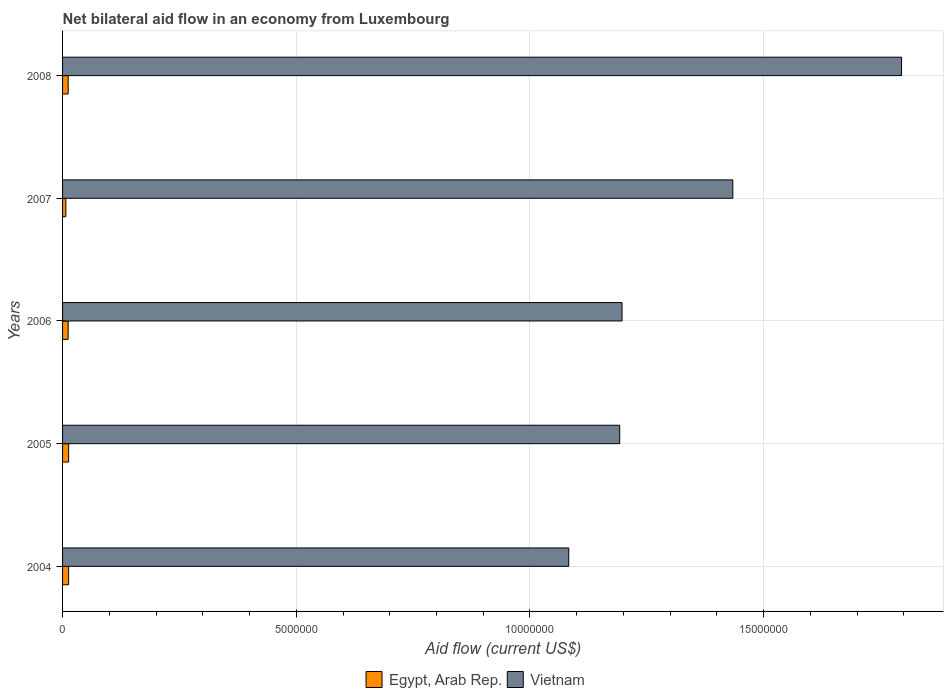How many groups of bars are there?
Your answer should be compact. 5. Are the number of bars per tick equal to the number of legend labels?
Your answer should be very brief. Yes. Are the number of bars on each tick of the Y-axis equal?
Your answer should be compact. Yes. How many bars are there on the 2nd tick from the bottom?
Keep it short and to the point. 2. What is the label of the 3rd group of bars from the top?
Ensure brevity in your answer.  2006. What is the net bilateral aid flow in Egypt, Arab Rep. in 2006?
Provide a succinct answer. 1.20e+05. Across all years, what is the maximum net bilateral aid flow in Vietnam?
Offer a very short reply. 1.80e+07. Across all years, what is the minimum net bilateral aid flow in Vietnam?
Make the answer very short. 1.08e+07. In which year was the net bilateral aid flow in Egypt, Arab Rep. maximum?
Make the answer very short. 2004. In which year was the net bilateral aid flow in Vietnam minimum?
Provide a short and direct response. 2004. What is the total net bilateral aid flow in Egypt, Arab Rep. in the graph?
Provide a short and direct response. 5.70e+05. What is the difference between the net bilateral aid flow in Egypt, Arab Rep. in 2004 and that in 2008?
Give a very brief answer. 10000. What is the difference between the net bilateral aid flow in Vietnam in 2005 and the net bilateral aid flow in Egypt, Arab Rep. in 2008?
Provide a short and direct response. 1.18e+07. What is the average net bilateral aid flow in Vietnam per year?
Provide a short and direct response. 1.34e+07. In the year 2007, what is the difference between the net bilateral aid flow in Vietnam and net bilateral aid flow in Egypt, Arab Rep.?
Offer a very short reply. 1.43e+07. In how many years, is the net bilateral aid flow in Egypt, Arab Rep. greater than 16000000 US$?
Keep it short and to the point. 0. What is the ratio of the net bilateral aid flow in Vietnam in 2004 to that in 2005?
Your answer should be compact. 0.91. Is the difference between the net bilateral aid flow in Vietnam in 2005 and 2007 greater than the difference between the net bilateral aid flow in Egypt, Arab Rep. in 2005 and 2007?
Your response must be concise. No. What is the difference between the highest and the second highest net bilateral aid flow in Egypt, Arab Rep.?
Give a very brief answer. 0. What is the difference between the highest and the lowest net bilateral aid flow in Egypt, Arab Rep.?
Offer a terse response. 6.00e+04. In how many years, is the net bilateral aid flow in Vietnam greater than the average net bilateral aid flow in Vietnam taken over all years?
Your response must be concise. 2. What does the 2nd bar from the top in 2006 represents?
Keep it short and to the point. Egypt, Arab Rep. What does the 1st bar from the bottom in 2006 represents?
Your answer should be very brief. Egypt, Arab Rep. How many bars are there?
Give a very brief answer. 10. Are all the bars in the graph horizontal?
Provide a succinct answer. Yes. What is the difference between two consecutive major ticks on the X-axis?
Keep it short and to the point. 5.00e+06. Are the values on the major ticks of X-axis written in scientific E-notation?
Provide a succinct answer. No. Where does the legend appear in the graph?
Ensure brevity in your answer.  Bottom center. How are the legend labels stacked?
Your answer should be very brief. Horizontal. What is the title of the graph?
Your response must be concise. Net bilateral aid flow in an economy from Luxembourg. Does "Ireland" appear as one of the legend labels in the graph?
Make the answer very short. No. What is the label or title of the X-axis?
Provide a short and direct response. Aid flow (current US$). What is the Aid flow (current US$) in Vietnam in 2004?
Ensure brevity in your answer.  1.08e+07. What is the Aid flow (current US$) in Vietnam in 2005?
Ensure brevity in your answer.  1.19e+07. What is the Aid flow (current US$) of Egypt, Arab Rep. in 2006?
Your response must be concise. 1.20e+05. What is the Aid flow (current US$) in Vietnam in 2006?
Provide a short and direct response. 1.20e+07. What is the Aid flow (current US$) of Vietnam in 2007?
Provide a short and direct response. 1.43e+07. What is the Aid flow (current US$) in Vietnam in 2008?
Provide a short and direct response. 1.80e+07. Across all years, what is the maximum Aid flow (current US$) in Egypt, Arab Rep.?
Ensure brevity in your answer.  1.30e+05. Across all years, what is the maximum Aid flow (current US$) of Vietnam?
Your answer should be very brief. 1.80e+07. Across all years, what is the minimum Aid flow (current US$) in Vietnam?
Your answer should be very brief. 1.08e+07. What is the total Aid flow (current US$) in Egypt, Arab Rep. in the graph?
Keep it short and to the point. 5.70e+05. What is the total Aid flow (current US$) of Vietnam in the graph?
Your response must be concise. 6.70e+07. What is the difference between the Aid flow (current US$) in Egypt, Arab Rep. in 2004 and that in 2005?
Provide a succinct answer. 0. What is the difference between the Aid flow (current US$) in Vietnam in 2004 and that in 2005?
Keep it short and to the point. -1.09e+06. What is the difference between the Aid flow (current US$) of Egypt, Arab Rep. in 2004 and that in 2006?
Provide a short and direct response. 10000. What is the difference between the Aid flow (current US$) in Vietnam in 2004 and that in 2006?
Provide a succinct answer. -1.14e+06. What is the difference between the Aid flow (current US$) in Vietnam in 2004 and that in 2007?
Provide a short and direct response. -3.51e+06. What is the difference between the Aid flow (current US$) in Egypt, Arab Rep. in 2004 and that in 2008?
Your answer should be compact. 10000. What is the difference between the Aid flow (current US$) in Vietnam in 2004 and that in 2008?
Your answer should be very brief. -7.12e+06. What is the difference between the Aid flow (current US$) in Egypt, Arab Rep. in 2005 and that in 2006?
Give a very brief answer. 10000. What is the difference between the Aid flow (current US$) of Vietnam in 2005 and that in 2006?
Make the answer very short. -5.00e+04. What is the difference between the Aid flow (current US$) of Egypt, Arab Rep. in 2005 and that in 2007?
Keep it short and to the point. 6.00e+04. What is the difference between the Aid flow (current US$) of Vietnam in 2005 and that in 2007?
Your answer should be compact. -2.42e+06. What is the difference between the Aid flow (current US$) in Egypt, Arab Rep. in 2005 and that in 2008?
Your answer should be compact. 10000. What is the difference between the Aid flow (current US$) of Vietnam in 2005 and that in 2008?
Provide a succinct answer. -6.03e+06. What is the difference between the Aid flow (current US$) of Egypt, Arab Rep. in 2006 and that in 2007?
Give a very brief answer. 5.00e+04. What is the difference between the Aid flow (current US$) in Vietnam in 2006 and that in 2007?
Make the answer very short. -2.37e+06. What is the difference between the Aid flow (current US$) in Egypt, Arab Rep. in 2006 and that in 2008?
Your response must be concise. 0. What is the difference between the Aid flow (current US$) in Vietnam in 2006 and that in 2008?
Your answer should be very brief. -5.98e+06. What is the difference between the Aid flow (current US$) in Egypt, Arab Rep. in 2007 and that in 2008?
Give a very brief answer. -5.00e+04. What is the difference between the Aid flow (current US$) in Vietnam in 2007 and that in 2008?
Offer a very short reply. -3.61e+06. What is the difference between the Aid flow (current US$) in Egypt, Arab Rep. in 2004 and the Aid flow (current US$) in Vietnam in 2005?
Your answer should be compact. -1.18e+07. What is the difference between the Aid flow (current US$) in Egypt, Arab Rep. in 2004 and the Aid flow (current US$) in Vietnam in 2006?
Offer a terse response. -1.18e+07. What is the difference between the Aid flow (current US$) of Egypt, Arab Rep. in 2004 and the Aid flow (current US$) of Vietnam in 2007?
Offer a very short reply. -1.42e+07. What is the difference between the Aid flow (current US$) in Egypt, Arab Rep. in 2004 and the Aid flow (current US$) in Vietnam in 2008?
Give a very brief answer. -1.78e+07. What is the difference between the Aid flow (current US$) in Egypt, Arab Rep. in 2005 and the Aid flow (current US$) in Vietnam in 2006?
Provide a succinct answer. -1.18e+07. What is the difference between the Aid flow (current US$) in Egypt, Arab Rep. in 2005 and the Aid flow (current US$) in Vietnam in 2007?
Provide a short and direct response. -1.42e+07. What is the difference between the Aid flow (current US$) in Egypt, Arab Rep. in 2005 and the Aid flow (current US$) in Vietnam in 2008?
Offer a very short reply. -1.78e+07. What is the difference between the Aid flow (current US$) of Egypt, Arab Rep. in 2006 and the Aid flow (current US$) of Vietnam in 2007?
Make the answer very short. -1.42e+07. What is the difference between the Aid flow (current US$) in Egypt, Arab Rep. in 2006 and the Aid flow (current US$) in Vietnam in 2008?
Make the answer very short. -1.78e+07. What is the difference between the Aid flow (current US$) in Egypt, Arab Rep. in 2007 and the Aid flow (current US$) in Vietnam in 2008?
Provide a succinct answer. -1.79e+07. What is the average Aid flow (current US$) in Egypt, Arab Rep. per year?
Your response must be concise. 1.14e+05. What is the average Aid flow (current US$) in Vietnam per year?
Ensure brevity in your answer.  1.34e+07. In the year 2004, what is the difference between the Aid flow (current US$) in Egypt, Arab Rep. and Aid flow (current US$) in Vietnam?
Your answer should be very brief. -1.07e+07. In the year 2005, what is the difference between the Aid flow (current US$) in Egypt, Arab Rep. and Aid flow (current US$) in Vietnam?
Provide a succinct answer. -1.18e+07. In the year 2006, what is the difference between the Aid flow (current US$) of Egypt, Arab Rep. and Aid flow (current US$) of Vietnam?
Make the answer very short. -1.18e+07. In the year 2007, what is the difference between the Aid flow (current US$) in Egypt, Arab Rep. and Aid flow (current US$) in Vietnam?
Offer a very short reply. -1.43e+07. In the year 2008, what is the difference between the Aid flow (current US$) in Egypt, Arab Rep. and Aid flow (current US$) in Vietnam?
Offer a very short reply. -1.78e+07. What is the ratio of the Aid flow (current US$) of Egypt, Arab Rep. in 2004 to that in 2005?
Your response must be concise. 1. What is the ratio of the Aid flow (current US$) of Vietnam in 2004 to that in 2005?
Make the answer very short. 0.91. What is the ratio of the Aid flow (current US$) of Egypt, Arab Rep. in 2004 to that in 2006?
Provide a short and direct response. 1.08. What is the ratio of the Aid flow (current US$) of Vietnam in 2004 to that in 2006?
Provide a succinct answer. 0.9. What is the ratio of the Aid flow (current US$) of Egypt, Arab Rep. in 2004 to that in 2007?
Ensure brevity in your answer.  1.86. What is the ratio of the Aid flow (current US$) of Vietnam in 2004 to that in 2007?
Ensure brevity in your answer.  0.76. What is the ratio of the Aid flow (current US$) of Vietnam in 2004 to that in 2008?
Provide a succinct answer. 0.6. What is the ratio of the Aid flow (current US$) in Egypt, Arab Rep. in 2005 to that in 2006?
Your answer should be very brief. 1.08. What is the ratio of the Aid flow (current US$) of Vietnam in 2005 to that in 2006?
Your answer should be very brief. 1. What is the ratio of the Aid flow (current US$) in Egypt, Arab Rep. in 2005 to that in 2007?
Make the answer very short. 1.86. What is the ratio of the Aid flow (current US$) of Vietnam in 2005 to that in 2007?
Provide a succinct answer. 0.83. What is the ratio of the Aid flow (current US$) in Egypt, Arab Rep. in 2005 to that in 2008?
Your response must be concise. 1.08. What is the ratio of the Aid flow (current US$) in Vietnam in 2005 to that in 2008?
Your answer should be compact. 0.66. What is the ratio of the Aid flow (current US$) in Egypt, Arab Rep. in 2006 to that in 2007?
Provide a succinct answer. 1.71. What is the ratio of the Aid flow (current US$) in Vietnam in 2006 to that in 2007?
Provide a succinct answer. 0.83. What is the ratio of the Aid flow (current US$) of Egypt, Arab Rep. in 2006 to that in 2008?
Ensure brevity in your answer.  1. What is the ratio of the Aid flow (current US$) in Vietnam in 2006 to that in 2008?
Provide a succinct answer. 0.67. What is the ratio of the Aid flow (current US$) in Egypt, Arab Rep. in 2007 to that in 2008?
Offer a terse response. 0.58. What is the ratio of the Aid flow (current US$) of Vietnam in 2007 to that in 2008?
Offer a terse response. 0.8. What is the difference between the highest and the second highest Aid flow (current US$) in Egypt, Arab Rep.?
Offer a very short reply. 0. What is the difference between the highest and the second highest Aid flow (current US$) in Vietnam?
Provide a succinct answer. 3.61e+06. What is the difference between the highest and the lowest Aid flow (current US$) in Vietnam?
Your response must be concise. 7.12e+06. 